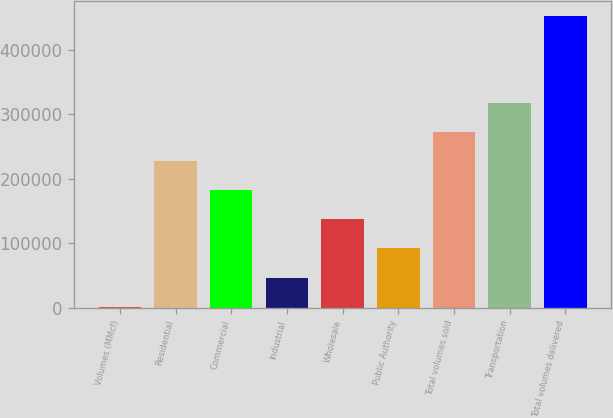<chart> <loc_0><loc_0><loc_500><loc_500><bar_chart><fcel>Volumes (MMcf)<fcel>Residential<fcel>Commercial<fcel>Industrial<fcel>Wholesale<fcel>Public Authority<fcel>Total volumes sold<fcel>Transportation<fcel>Total volumes delivered<nl><fcel>2005<fcel>227000<fcel>182001<fcel>47004.1<fcel>137002<fcel>92003.2<fcel>272000<fcel>316999<fcel>451996<nl></chart> 